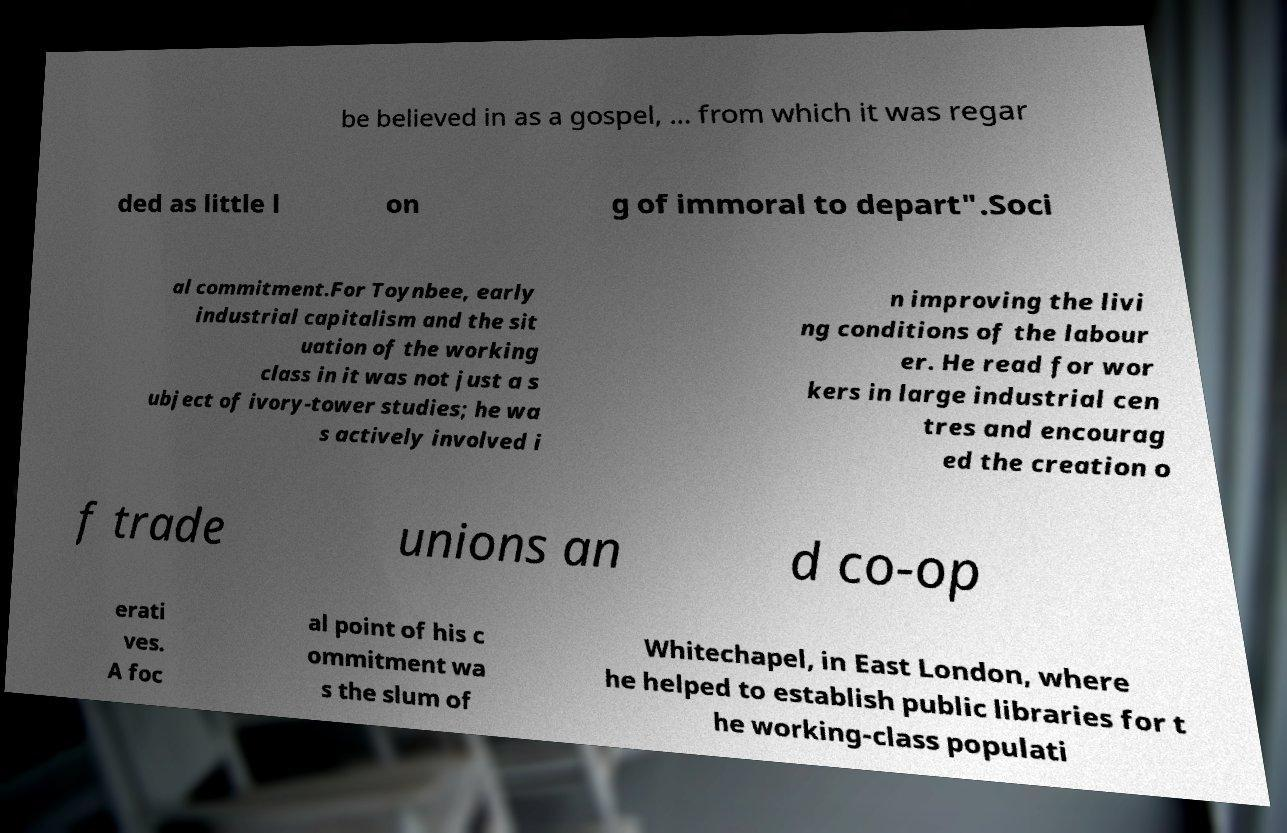Please read and relay the text visible in this image. What does it say? be believed in as a gospel, ... from which it was regar ded as little l on g of immoral to depart".Soci al commitment.For Toynbee, early industrial capitalism and the sit uation of the working class in it was not just a s ubject of ivory-tower studies; he wa s actively involved i n improving the livi ng conditions of the labour er. He read for wor kers in large industrial cen tres and encourag ed the creation o f trade unions an d co-op erati ves. A foc al point of his c ommitment wa s the slum of Whitechapel, in East London, where he helped to establish public libraries for t he working-class populati 